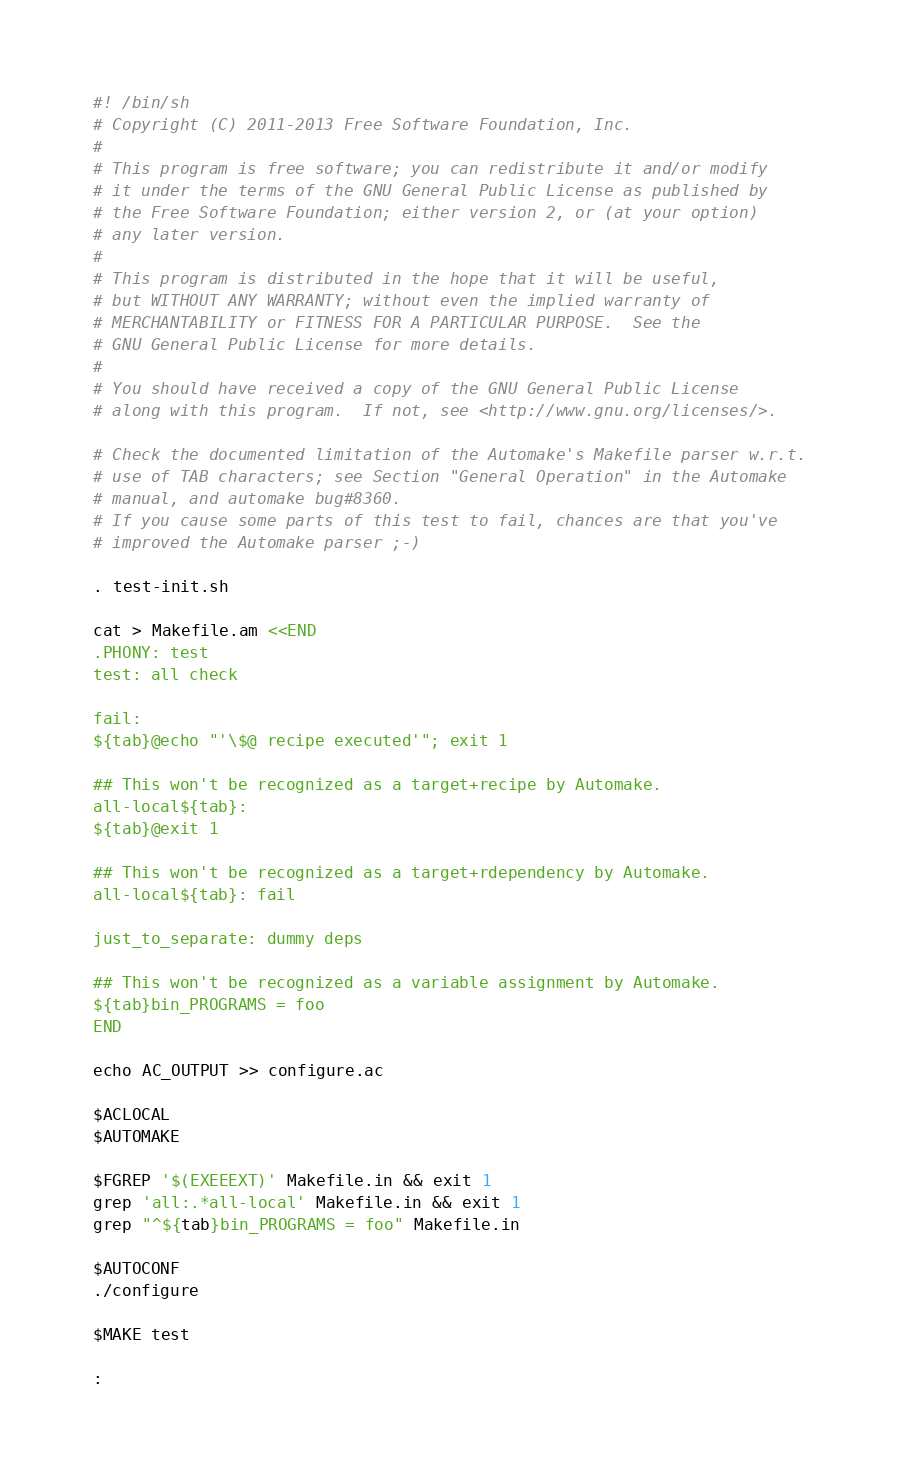<code> <loc_0><loc_0><loc_500><loc_500><_Bash_>#! /bin/sh
# Copyright (C) 2011-2013 Free Software Foundation, Inc.
#
# This program is free software; you can redistribute it and/or modify
# it under the terms of the GNU General Public License as published by
# the Free Software Foundation; either version 2, or (at your option)
# any later version.
#
# This program is distributed in the hope that it will be useful,
# but WITHOUT ANY WARRANTY; without even the implied warranty of
# MERCHANTABILITY or FITNESS FOR A PARTICULAR PURPOSE.  See the
# GNU General Public License for more details.
#
# You should have received a copy of the GNU General Public License
# along with this program.  If not, see <http://www.gnu.org/licenses/>.

# Check the documented limitation of the Automake's Makefile parser w.r.t.
# use of TAB characters; see Section "General Operation" in the Automake
# manual, and automake bug#8360.
# If you cause some parts of this test to fail, chances are that you've
# improved the Automake parser ;-)

. test-init.sh

cat > Makefile.am <<END
.PHONY: test
test: all check

fail:
${tab}@echo "'\$@ recipe executed'"; exit 1

## This won't be recognized as a target+recipe by Automake.
all-local${tab}:
${tab}@exit 1

## This won't be recognized as a target+rdependency by Automake.
all-local${tab}: fail

just_to_separate: dummy deps

## This won't be recognized as a variable assignment by Automake.
${tab}bin_PROGRAMS = foo
END

echo AC_OUTPUT >> configure.ac

$ACLOCAL
$AUTOMAKE

$FGREP '$(EXEEEXT)' Makefile.in && exit 1
grep 'all:.*all-local' Makefile.in && exit 1
grep "^${tab}bin_PROGRAMS = foo" Makefile.in

$AUTOCONF
./configure

$MAKE test

:
</code> 